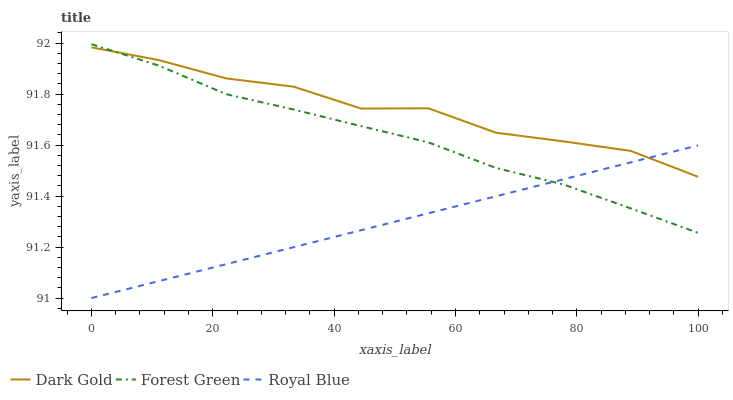Does Royal Blue have the minimum area under the curve?
Answer yes or no. Yes. Does Dark Gold have the maximum area under the curve?
Answer yes or no. Yes. Does Forest Green have the minimum area under the curve?
Answer yes or no. No. Does Forest Green have the maximum area under the curve?
Answer yes or no. No. Is Royal Blue the smoothest?
Answer yes or no. Yes. Is Dark Gold the roughest?
Answer yes or no. Yes. Is Forest Green the smoothest?
Answer yes or no. No. Is Forest Green the roughest?
Answer yes or no. No. Does Royal Blue have the lowest value?
Answer yes or no. Yes. Does Forest Green have the lowest value?
Answer yes or no. No. Does Forest Green have the highest value?
Answer yes or no. Yes. Does Dark Gold have the highest value?
Answer yes or no. No. Does Dark Gold intersect Forest Green?
Answer yes or no. Yes. Is Dark Gold less than Forest Green?
Answer yes or no. No. Is Dark Gold greater than Forest Green?
Answer yes or no. No. 